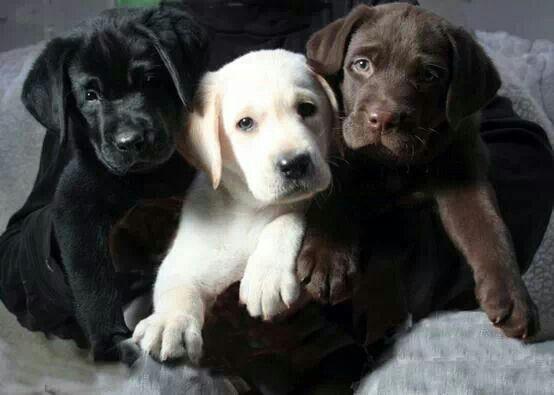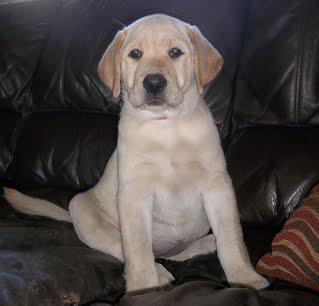The first image is the image on the left, the second image is the image on the right. Considering the images on both sides, is "6 dogs exactly can be seen." valid? Answer yes or no. No. The first image is the image on the left, the second image is the image on the right. Examine the images to the left and right. Is the description "An image shows three upright, non-reclining dogs posed with the black dog on the far left and the brown dog on the far right." accurate? Answer yes or no. No. 